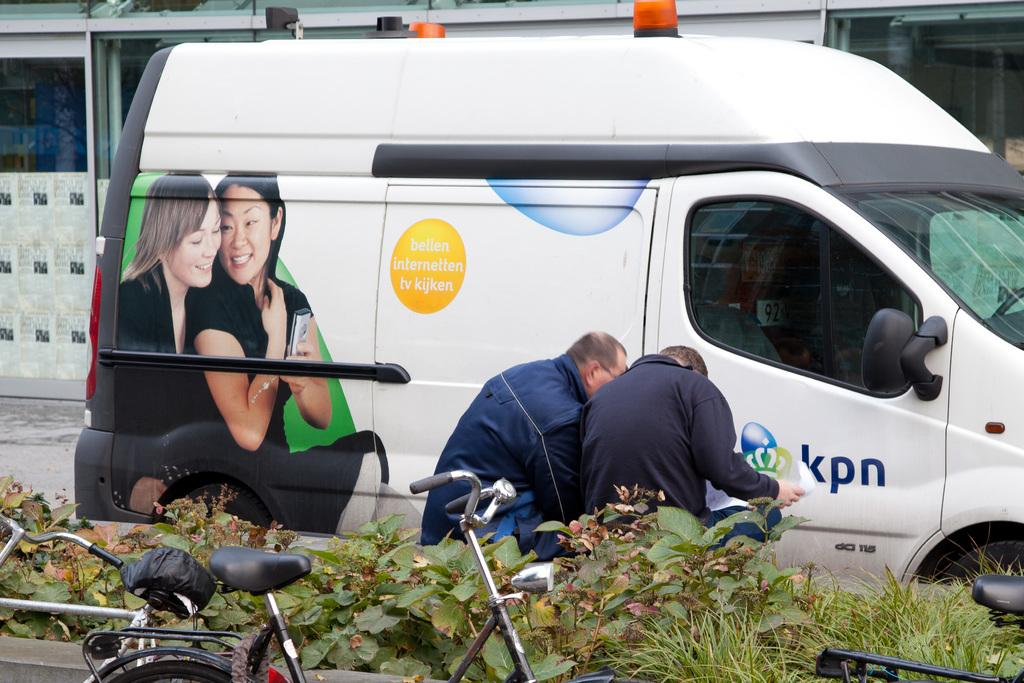<image>
Write a terse but informative summary of the picture. A van has the phrase "bellen internetten tv kijken" on the side of it. 